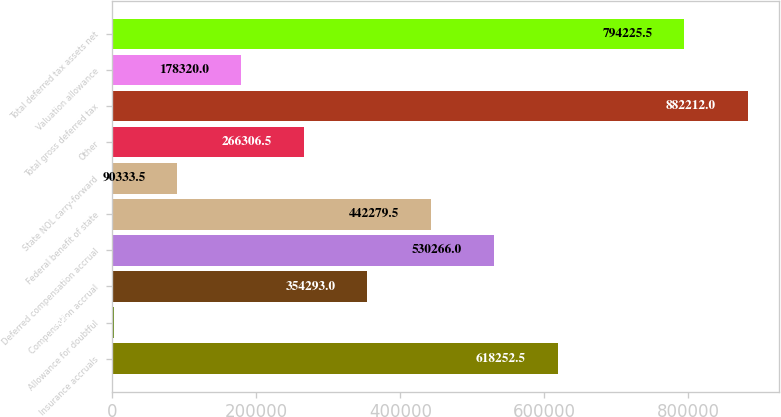Convert chart to OTSL. <chart><loc_0><loc_0><loc_500><loc_500><bar_chart><fcel>Insurance accruals<fcel>Allowance for doubtful<fcel>Compensation accrual<fcel>Deferred compensation accrual<fcel>Federal benefit of state<fcel>State NOL carry-forward<fcel>Other<fcel>Total gross deferred tax<fcel>Valuation allowance<fcel>Total deferred tax assets net<nl><fcel>618252<fcel>2347<fcel>354293<fcel>530266<fcel>442280<fcel>90333.5<fcel>266306<fcel>882212<fcel>178320<fcel>794226<nl></chart> 